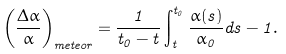Convert formula to latex. <formula><loc_0><loc_0><loc_500><loc_500>\left ( \frac { \Delta \alpha } { \alpha } \right ) _ { m e t e o r } = \frac { 1 } { t _ { 0 } - t } \int _ { t } ^ { t _ { 0 } } \frac { \alpha ( s ) } { \alpha _ { 0 } } d s - 1 .</formula> 